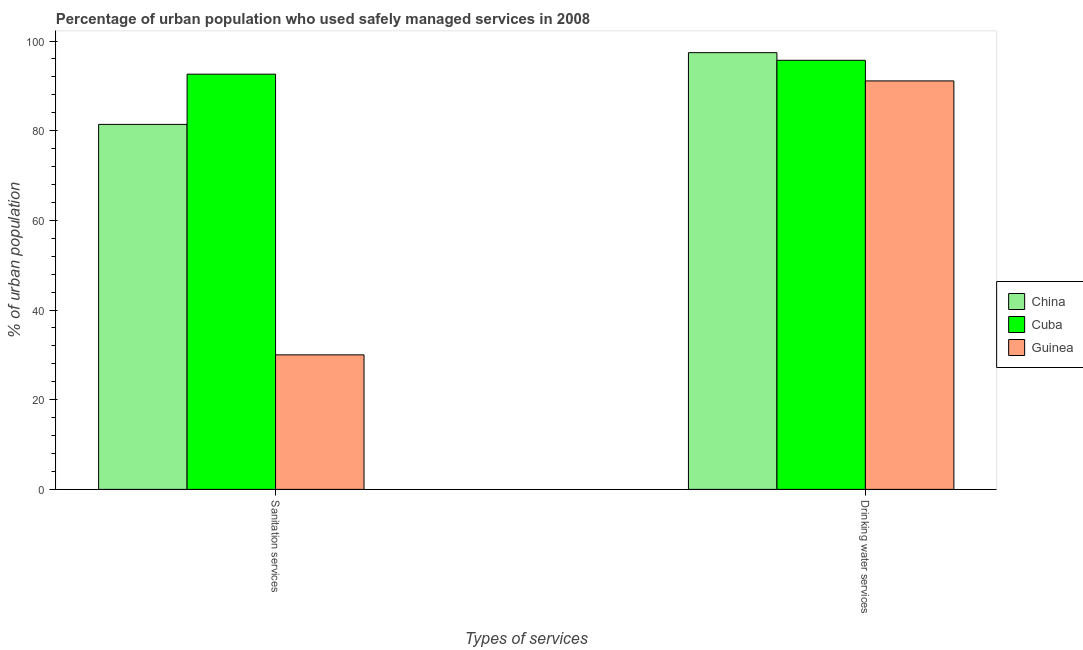Are the number of bars per tick equal to the number of legend labels?
Provide a short and direct response. Yes. How many bars are there on the 2nd tick from the right?
Give a very brief answer. 3. What is the label of the 2nd group of bars from the left?
Your answer should be very brief. Drinking water services. Across all countries, what is the maximum percentage of urban population who used drinking water services?
Make the answer very short. 97.4. In which country was the percentage of urban population who used sanitation services maximum?
Give a very brief answer. Cuba. In which country was the percentage of urban population who used drinking water services minimum?
Your response must be concise. Guinea. What is the total percentage of urban population who used drinking water services in the graph?
Offer a very short reply. 284.2. What is the difference between the percentage of urban population who used drinking water services in Guinea and that in China?
Ensure brevity in your answer.  -6.3. What is the average percentage of urban population who used drinking water services per country?
Ensure brevity in your answer.  94.73. What is the difference between the percentage of urban population who used sanitation services and percentage of urban population who used drinking water services in China?
Provide a short and direct response. -16. What is the ratio of the percentage of urban population who used drinking water services in Cuba to that in China?
Offer a very short reply. 0.98. In how many countries, is the percentage of urban population who used sanitation services greater than the average percentage of urban population who used sanitation services taken over all countries?
Offer a terse response. 2. What does the 2nd bar from the left in Drinking water services represents?
Your answer should be very brief. Cuba. What does the 2nd bar from the right in Sanitation services represents?
Provide a succinct answer. Cuba. What is the difference between two consecutive major ticks on the Y-axis?
Your answer should be compact. 20. Are the values on the major ticks of Y-axis written in scientific E-notation?
Make the answer very short. No. Does the graph contain any zero values?
Your response must be concise. No. Does the graph contain grids?
Offer a terse response. No. Where does the legend appear in the graph?
Keep it short and to the point. Center right. What is the title of the graph?
Give a very brief answer. Percentage of urban population who used safely managed services in 2008. What is the label or title of the X-axis?
Your answer should be very brief. Types of services. What is the label or title of the Y-axis?
Give a very brief answer. % of urban population. What is the % of urban population of China in Sanitation services?
Provide a short and direct response. 81.4. What is the % of urban population in Cuba in Sanitation services?
Provide a short and direct response. 92.6. What is the % of urban population of Guinea in Sanitation services?
Your answer should be compact. 30. What is the % of urban population in China in Drinking water services?
Keep it short and to the point. 97.4. What is the % of urban population of Cuba in Drinking water services?
Keep it short and to the point. 95.7. What is the % of urban population in Guinea in Drinking water services?
Your answer should be very brief. 91.1. Across all Types of services, what is the maximum % of urban population in China?
Make the answer very short. 97.4. Across all Types of services, what is the maximum % of urban population in Cuba?
Provide a succinct answer. 95.7. Across all Types of services, what is the maximum % of urban population in Guinea?
Your answer should be very brief. 91.1. Across all Types of services, what is the minimum % of urban population in China?
Provide a succinct answer. 81.4. Across all Types of services, what is the minimum % of urban population of Cuba?
Offer a very short reply. 92.6. What is the total % of urban population of China in the graph?
Provide a short and direct response. 178.8. What is the total % of urban population of Cuba in the graph?
Ensure brevity in your answer.  188.3. What is the total % of urban population of Guinea in the graph?
Give a very brief answer. 121.1. What is the difference between the % of urban population of China in Sanitation services and that in Drinking water services?
Offer a very short reply. -16. What is the difference between the % of urban population of Cuba in Sanitation services and that in Drinking water services?
Make the answer very short. -3.1. What is the difference between the % of urban population in Guinea in Sanitation services and that in Drinking water services?
Your answer should be very brief. -61.1. What is the difference between the % of urban population of China in Sanitation services and the % of urban population of Cuba in Drinking water services?
Make the answer very short. -14.3. What is the difference between the % of urban population of China in Sanitation services and the % of urban population of Guinea in Drinking water services?
Ensure brevity in your answer.  -9.7. What is the average % of urban population of China per Types of services?
Ensure brevity in your answer.  89.4. What is the average % of urban population in Cuba per Types of services?
Make the answer very short. 94.15. What is the average % of urban population in Guinea per Types of services?
Your answer should be very brief. 60.55. What is the difference between the % of urban population in China and % of urban population in Cuba in Sanitation services?
Offer a terse response. -11.2. What is the difference between the % of urban population of China and % of urban population of Guinea in Sanitation services?
Your response must be concise. 51.4. What is the difference between the % of urban population of Cuba and % of urban population of Guinea in Sanitation services?
Provide a short and direct response. 62.6. What is the difference between the % of urban population of China and % of urban population of Cuba in Drinking water services?
Make the answer very short. 1.7. What is the difference between the % of urban population in China and % of urban population in Guinea in Drinking water services?
Make the answer very short. 6.3. What is the ratio of the % of urban population in China in Sanitation services to that in Drinking water services?
Provide a short and direct response. 0.84. What is the ratio of the % of urban population in Cuba in Sanitation services to that in Drinking water services?
Offer a very short reply. 0.97. What is the ratio of the % of urban population of Guinea in Sanitation services to that in Drinking water services?
Offer a very short reply. 0.33. What is the difference between the highest and the second highest % of urban population of China?
Make the answer very short. 16. What is the difference between the highest and the second highest % of urban population of Guinea?
Keep it short and to the point. 61.1. What is the difference between the highest and the lowest % of urban population of Cuba?
Keep it short and to the point. 3.1. What is the difference between the highest and the lowest % of urban population in Guinea?
Make the answer very short. 61.1. 